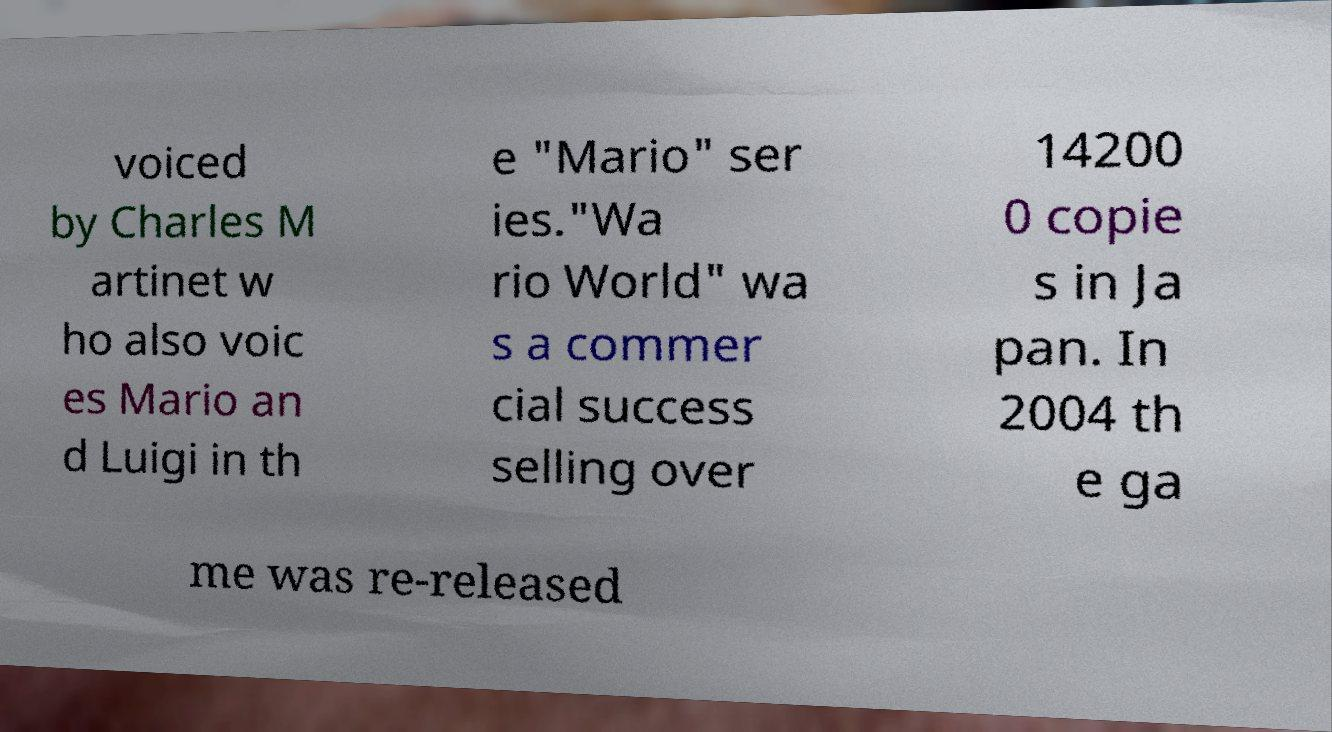Please identify and transcribe the text found in this image. voiced by Charles M artinet w ho also voic es Mario an d Luigi in th e "Mario" ser ies."Wa rio World" wa s a commer cial success selling over 14200 0 copie s in Ja pan. In 2004 th e ga me was re-released 